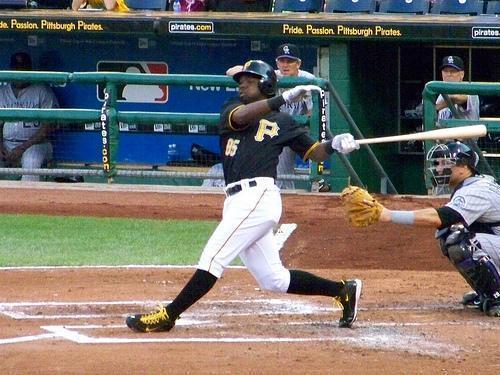How many people are there?
Give a very brief answer. 5. How many peole is crouched on the baseball field?
Give a very brief answer. 1. 